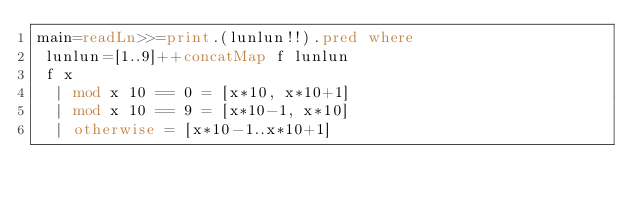Convert code to text. <code><loc_0><loc_0><loc_500><loc_500><_Haskell_>main=readLn>>=print.(lunlun!!).pred where
 lunlun=[1..9]++concatMap f lunlun
 f x
  | mod x 10 == 0 = [x*10, x*10+1]
  | mod x 10 == 9 = [x*10-1, x*10]
  | otherwise = [x*10-1..x*10+1]</code> 